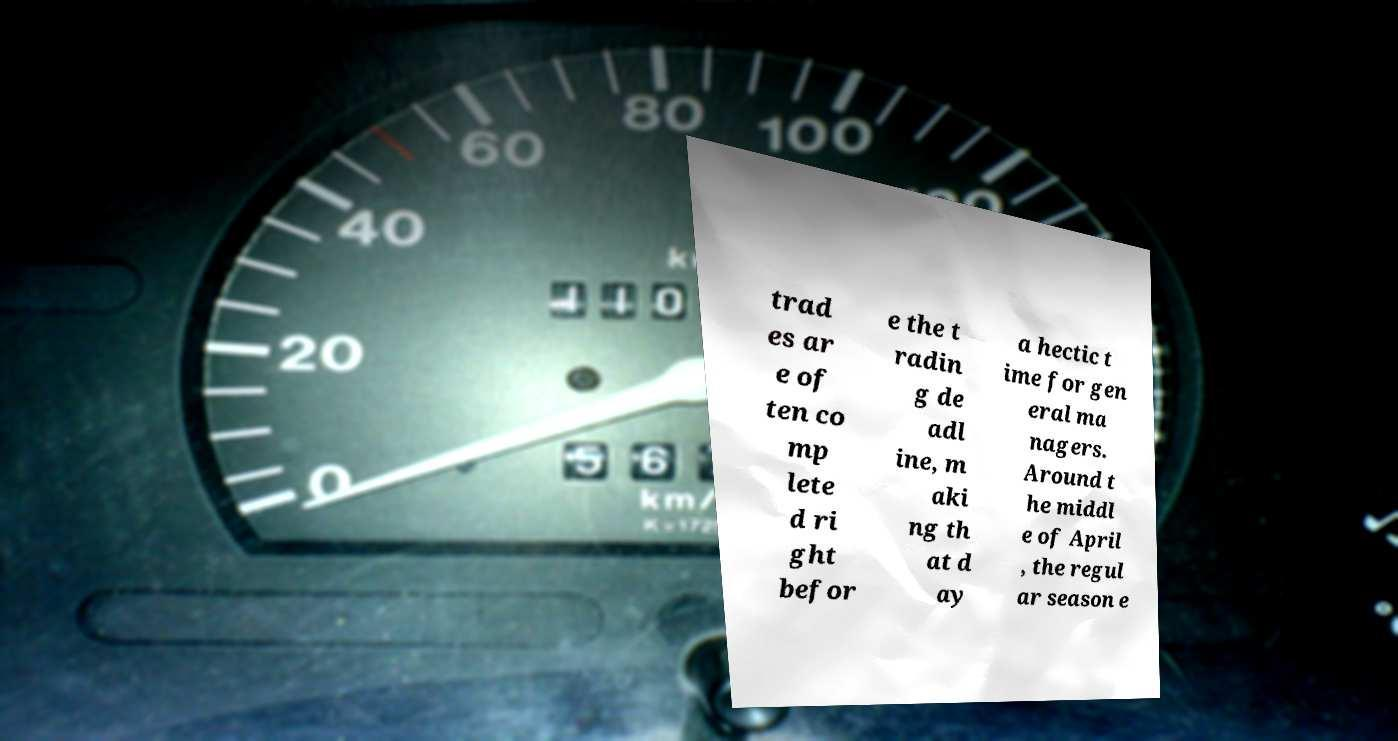Can you read and provide the text displayed in the image?This photo seems to have some interesting text. Can you extract and type it out for me? trad es ar e of ten co mp lete d ri ght befor e the t radin g de adl ine, m aki ng th at d ay a hectic t ime for gen eral ma nagers. Around t he middl e of April , the regul ar season e 